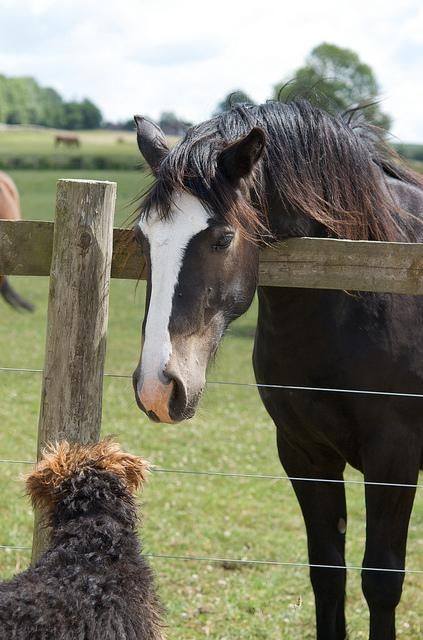This animal has a long what? snout 